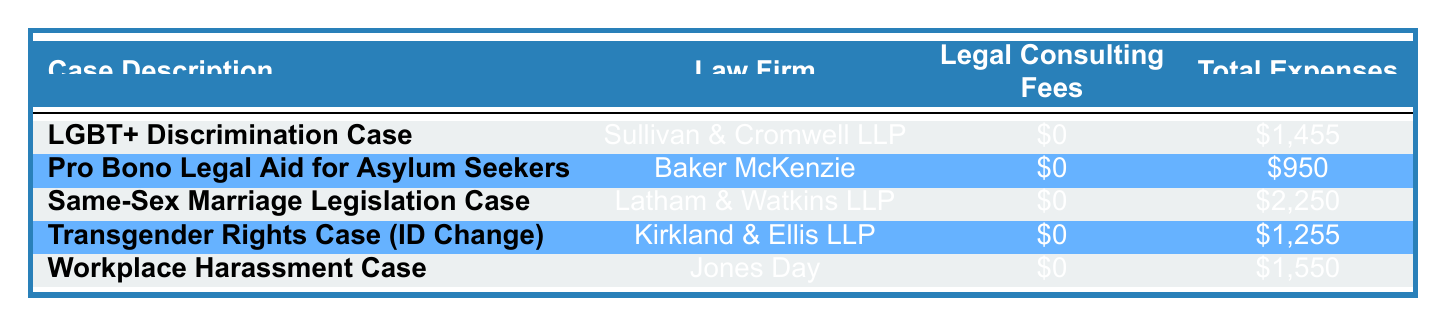What is the total amount of expenses for the LGBT+ Discrimination Case? The table shows the total expenses for the LGBT+ Discrimination Case as \$1,455.
Answer: 1,455 Which law firm is handling the Same-Sex Marriage Legislation Case? According to the table, the law firm handling the Same-Sex Marriage Legislation Case is Latham & Watkins LLP.
Answer: Latham & Watkins LLP How many cases have total expenses greater than \$1,500? The total expenses for the cases are \$1,455, \$950, \$2,250, \$1,255, and \$1,550. Only the Same-Sex Marriage Legislation Case has total expenses greater than \$1,500, which is \$2,250.
Answer: 1 Is there any case with legal consulting fees? The table shows that all the listed pro bono cases have legal consulting fees of \$0. Thus, there are no cases with legal consulting fees.
Answer: No What is the average of total expenses for all cases listed? The total expenses for the cases are as follows: \$1,455, \$950, \$2,250, \$1,255, and \$1,550. The sum of these amounts is \$1,455 + \$950 + \$2,250 + \$1,255 + \$1,550 = \$7,410. There are 5 cases, so the average is \$7,410 / 5 = \$1,482.
Answer: 1,482 How much did Baker McKenzie spend on court filing fees for the Pro Bono Legal Aid for Asylum Seekers? The table indicates that Baker McKenzie spent \$400 on court filing fees for the Pro Bono Legal Aid for Asylum Seekers.
Answer: 400 Which case has the highest total expenses, and what is that amount? The case with the highest total expenses is the Same-Sex Marriage Legislation Case, with total expenses of \$2,250.
Answer: Same-Sex Marriage Legislation Case - 2,250 What are the total expenses for Transgender Rights Case's document preparation? The Transgender Rights Case had a document preparation cost of \$125, making it part of the overall total expenses of \$1,255 for that case.
Answer: 125 